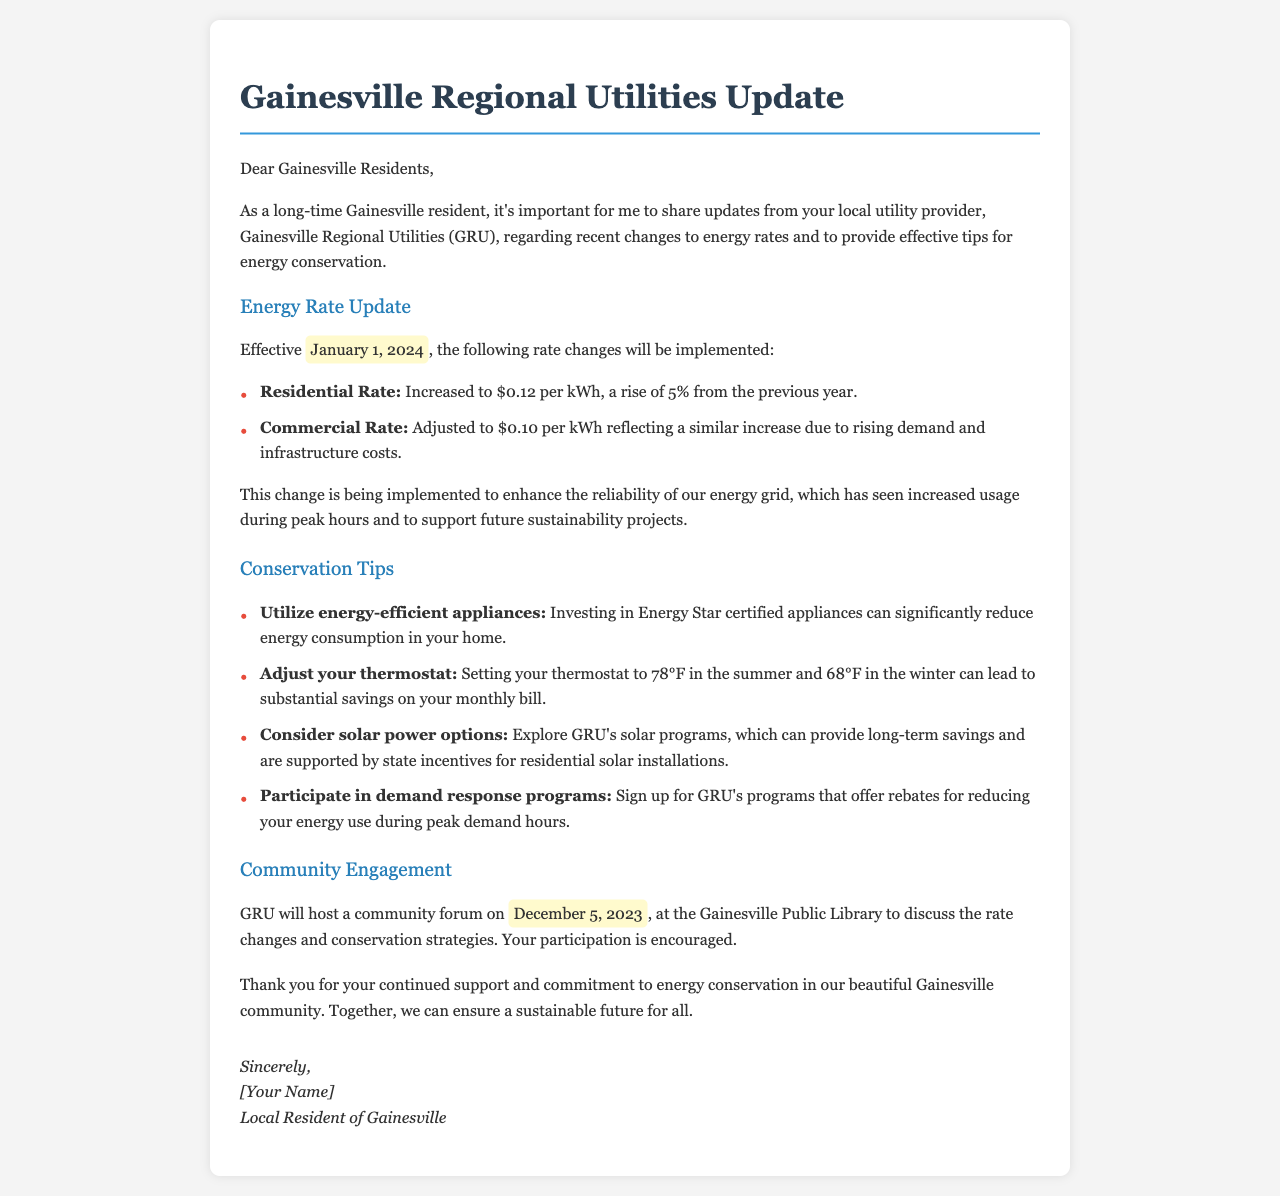What is the effective date of the new energy rates? The effective date for the new energy rates is mentioned in the document as January 1, 2024.
Answer: January 1, 2024 What is the new residential rate per kWh? The new residential rate is stated as $0.12 per kWh, which reflects a 5% increase.
Answer: $0.12 per kWh What percentage increase is the residential rate experiencing? The document specifies that the residential rate is increasing by 5% from the previous year.
Answer: 5% When is the community forum scheduled? The community forum is scheduled to be held on December 5, 2023, as mentioned in the document.
Answer: December 5, 2023 What is one tip for energy conservation mentioned in the letter? The letter lists various tips, one of which is to set your thermostat to 78°F in the summer.
Answer: Set your thermostat to 78°F What type of appliances should residents consider for energy efficiency? The document recommends that residents invest in Energy Star certified appliances to reduce energy consumption.
Answer: Energy Star certified appliances Why are energy rates being adjusted? The rates are being adjusted to enhance the reliability of the energy grid due to increased usage during peak hours.
Answer: To enhance reliability of the energy grid What program is available for residents who reduce energy use during peak demand hours? The document mentions a demand response program that offers rebates for reducing energy usage during peak demand hours.
Answer: Demand response programs 